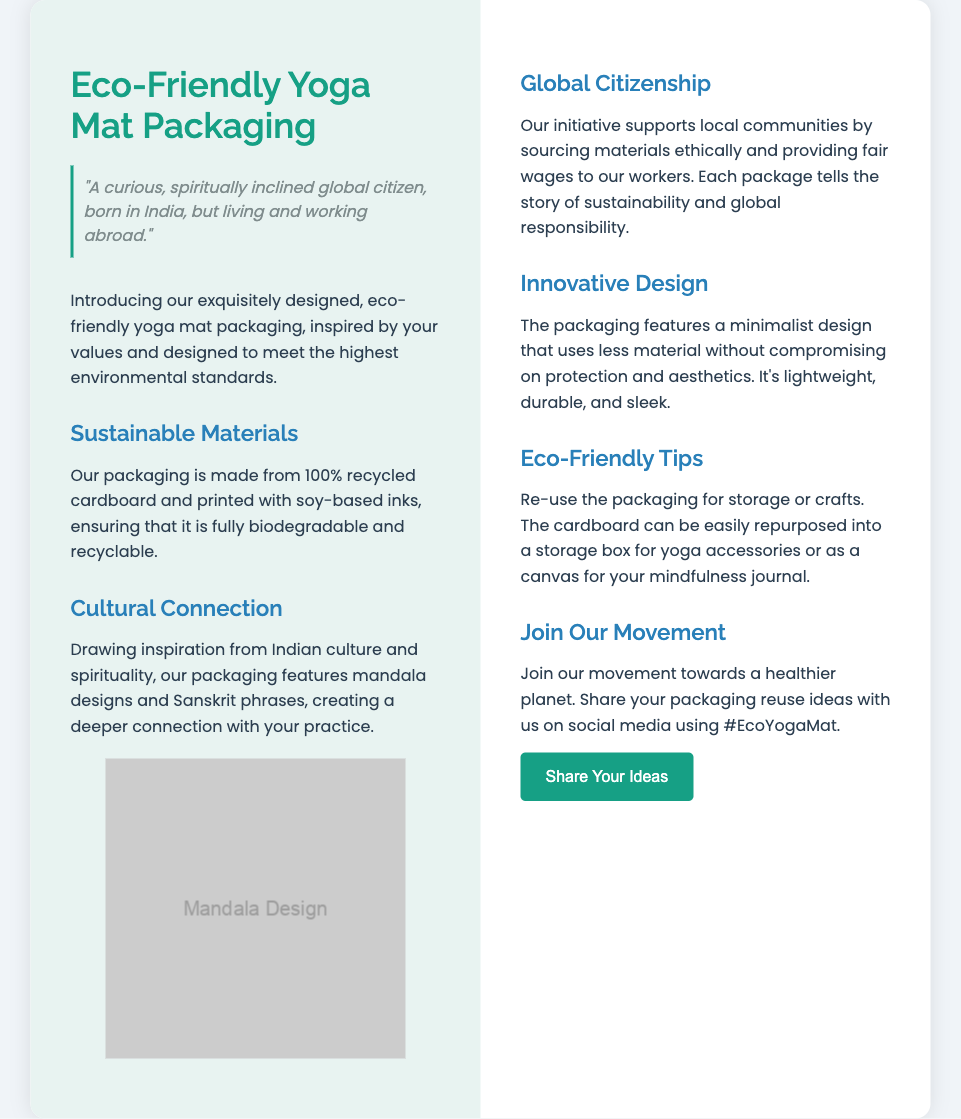What materials are used for the packaging? The packaging is made from 100% recycled cardboard and printed with soy-based inks.
Answer: 100% recycled cardboard and soy-based inks What is the cultural inspiration behind the packaging design? The packaging features mandala designs and Sanskrit phrases, connecting it with Indian culture and spirituality.
Answer: Indian culture and spirituality What initiative does the packaging support? The initiative supports local communities by sourcing materials ethically and providing fair wages to workers.
Answer: Local communities What is the design approach of the packaging? The packaging features a minimalist design that uses less material without compromising on protection and aesthetics.
Answer: Minimalist design What hashtag can customers use to share their ideas? The document mentions sharing packaging reuse ideas using a specific hashtag on social media.
Answer: #EcoYogaMat 